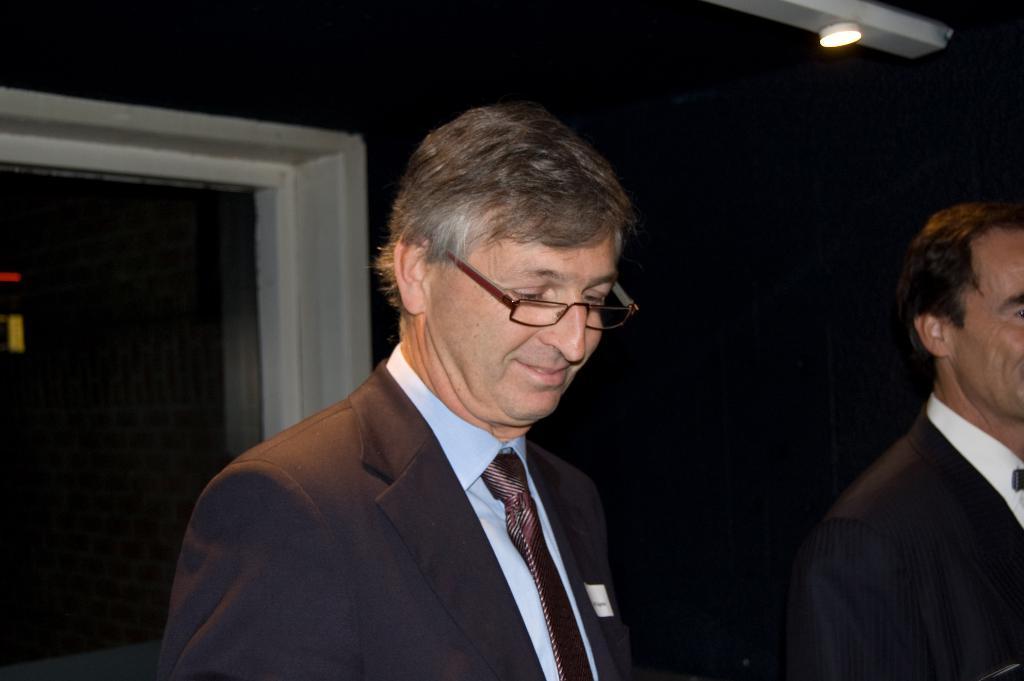In one or two sentences, can you explain what this image depicts? In this picture there is a person wearing suit and there is another person beside him and there is a light in the right top corner and there are some other objects in the background. 